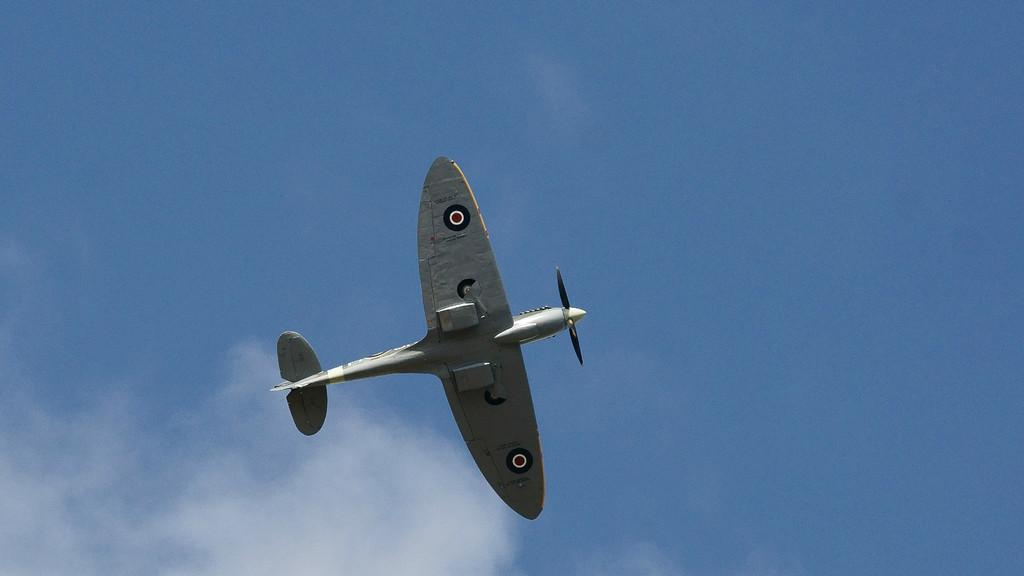What is the main subject of the image? The main subject of the image is an airplane. What is the airplane doing in the image? The airplane is flying in the sky. How would you describe the sky in the image? The sky is cloudy. Can you see the nose of the airplane in the image? There is no specific mention of the nose of the airplane in the image, but it is likely that the nose is visible as part of the airplane. Are there any fangs visible in the image? There are no fangs present in the image; it features an airplane flying in a cloudy sky. 